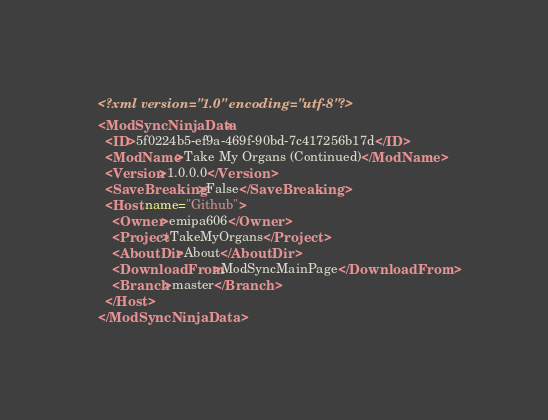Convert code to text. <code><loc_0><loc_0><loc_500><loc_500><_XML_><?xml version="1.0" encoding="utf-8"?>
<ModSyncNinjaData>
  <ID>5f0224b5-ef9a-469f-90bd-7c417256b17d</ID>
  <ModName>Take My Organs (Continued)</ModName>
  <Version>1.0.0.0</Version>
  <SaveBreaking>False</SaveBreaking>
  <Host name="Github">
    <Owner>emipa606</Owner>
    <Project>TakeMyOrgans</Project>
    <AboutDir>About</AboutDir>
    <DownloadFrom>ModSyncMainPage</DownloadFrom>
    <Branch>master</Branch>
  </Host>
</ModSyncNinjaData>




</code> 